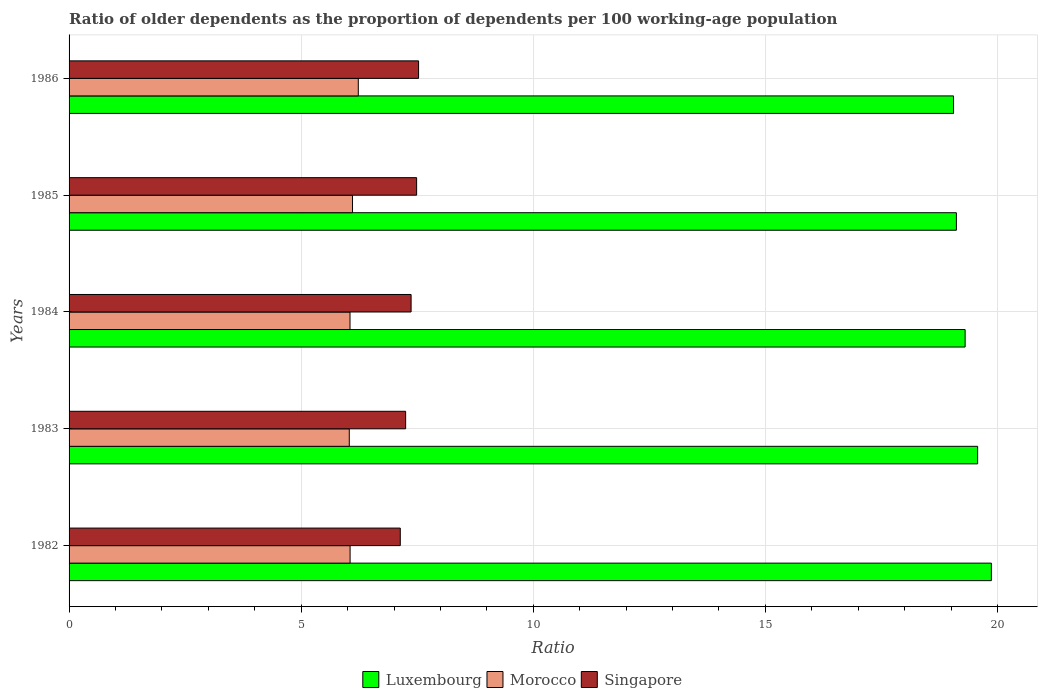How many different coloured bars are there?
Provide a short and direct response. 3. Are the number of bars on each tick of the Y-axis equal?
Your answer should be very brief. Yes. How many bars are there on the 1st tick from the bottom?
Your answer should be very brief. 3. What is the label of the 2nd group of bars from the top?
Your answer should be very brief. 1985. What is the age dependency ratio(old) in Morocco in 1986?
Offer a terse response. 6.23. Across all years, what is the maximum age dependency ratio(old) in Luxembourg?
Your answer should be compact. 19.87. Across all years, what is the minimum age dependency ratio(old) in Morocco?
Ensure brevity in your answer.  6.04. In which year was the age dependency ratio(old) in Morocco maximum?
Give a very brief answer. 1986. What is the total age dependency ratio(old) in Morocco in the graph?
Provide a short and direct response. 30.48. What is the difference between the age dependency ratio(old) in Luxembourg in 1984 and that in 1986?
Your answer should be very brief. 0.25. What is the difference between the age dependency ratio(old) in Luxembourg in 1983 and the age dependency ratio(old) in Morocco in 1982?
Offer a very short reply. 13.52. What is the average age dependency ratio(old) in Morocco per year?
Provide a short and direct response. 6.1. In the year 1985, what is the difference between the age dependency ratio(old) in Luxembourg and age dependency ratio(old) in Singapore?
Provide a short and direct response. 11.63. What is the ratio of the age dependency ratio(old) in Singapore in 1982 to that in 1985?
Offer a very short reply. 0.95. Is the difference between the age dependency ratio(old) in Luxembourg in 1982 and 1986 greater than the difference between the age dependency ratio(old) in Singapore in 1982 and 1986?
Your response must be concise. Yes. What is the difference between the highest and the second highest age dependency ratio(old) in Singapore?
Ensure brevity in your answer.  0.04. What is the difference between the highest and the lowest age dependency ratio(old) in Morocco?
Give a very brief answer. 0.19. In how many years, is the age dependency ratio(old) in Singapore greater than the average age dependency ratio(old) in Singapore taken over all years?
Give a very brief answer. 3. What does the 3rd bar from the top in 1985 represents?
Make the answer very short. Luxembourg. What does the 3rd bar from the bottom in 1982 represents?
Your response must be concise. Singapore. Is it the case that in every year, the sum of the age dependency ratio(old) in Singapore and age dependency ratio(old) in Luxembourg is greater than the age dependency ratio(old) in Morocco?
Your response must be concise. Yes. How many bars are there?
Ensure brevity in your answer.  15. Are all the bars in the graph horizontal?
Keep it short and to the point. Yes. What is the difference between two consecutive major ticks on the X-axis?
Your answer should be very brief. 5. Are the values on the major ticks of X-axis written in scientific E-notation?
Offer a very short reply. No. Does the graph contain any zero values?
Your answer should be very brief. No. Where does the legend appear in the graph?
Your answer should be very brief. Bottom center. How are the legend labels stacked?
Your answer should be compact. Horizontal. What is the title of the graph?
Offer a terse response. Ratio of older dependents as the proportion of dependents per 100 working-age population. What is the label or title of the X-axis?
Give a very brief answer. Ratio. What is the Ratio of Luxembourg in 1982?
Keep it short and to the point. 19.87. What is the Ratio in Morocco in 1982?
Offer a terse response. 6.05. What is the Ratio of Singapore in 1982?
Keep it short and to the point. 7.14. What is the Ratio in Luxembourg in 1983?
Your answer should be compact. 19.57. What is the Ratio of Morocco in 1983?
Ensure brevity in your answer.  6.04. What is the Ratio of Singapore in 1983?
Offer a terse response. 7.25. What is the Ratio in Luxembourg in 1984?
Keep it short and to the point. 19.3. What is the Ratio of Morocco in 1984?
Your answer should be compact. 6.05. What is the Ratio in Singapore in 1984?
Make the answer very short. 7.37. What is the Ratio in Luxembourg in 1985?
Keep it short and to the point. 19.12. What is the Ratio in Morocco in 1985?
Your answer should be very brief. 6.11. What is the Ratio of Singapore in 1985?
Your answer should be very brief. 7.49. What is the Ratio of Luxembourg in 1986?
Keep it short and to the point. 19.05. What is the Ratio of Morocco in 1986?
Provide a succinct answer. 6.23. What is the Ratio in Singapore in 1986?
Make the answer very short. 7.53. Across all years, what is the maximum Ratio in Luxembourg?
Provide a succinct answer. 19.87. Across all years, what is the maximum Ratio in Morocco?
Ensure brevity in your answer.  6.23. Across all years, what is the maximum Ratio in Singapore?
Your response must be concise. 7.53. Across all years, what is the minimum Ratio in Luxembourg?
Provide a succinct answer. 19.05. Across all years, what is the minimum Ratio in Morocco?
Your answer should be very brief. 6.04. Across all years, what is the minimum Ratio in Singapore?
Offer a terse response. 7.14. What is the total Ratio in Luxembourg in the graph?
Provide a succinct answer. 96.92. What is the total Ratio in Morocco in the graph?
Give a very brief answer. 30.48. What is the total Ratio in Singapore in the graph?
Offer a terse response. 36.77. What is the difference between the Ratio of Luxembourg in 1982 and that in 1983?
Your answer should be compact. 0.3. What is the difference between the Ratio of Morocco in 1982 and that in 1983?
Provide a short and direct response. 0.02. What is the difference between the Ratio of Singapore in 1982 and that in 1983?
Offer a terse response. -0.12. What is the difference between the Ratio of Luxembourg in 1982 and that in 1984?
Your answer should be compact. 0.57. What is the difference between the Ratio of Morocco in 1982 and that in 1984?
Your answer should be compact. 0. What is the difference between the Ratio of Singapore in 1982 and that in 1984?
Offer a terse response. -0.23. What is the difference between the Ratio in Luxembourg in 1982 and that in 1985?
Your answer should be very brief. 0.75. What is the difference between the Ratio in Morocco in 1982 and that in 1985?
Provide a short and direct response. -0.05. What is the difference between the Ratio in Singapore in 1982 and that in 1985?
Give a very brief answer. -0.35. What is the difference between the Ratio in Luxembourg in 1982 and that in 1986?
Offer a very short reply. 0.82. What is the difference between the Ratio in Morocco in 1982 and that in 1986?
Make the answer very short. -0.18. What is the difference between the Ratio of Singapore in 1982 and that in 1986?
Make the answer very short. -0.39. What is the difference between the Ratio of Luxembourg in 1983 and that in 1984?
Your response must be concise. 0.27. What is the difference between the Ratio in Morocco in 1983 and that in 1984?
Offer a terse response. -0.02. What is the difference between the Ratio of Singapore in 1983 and that in 1984?
Your answer should be very brief. -0.12. What is the difference between the Ratio of Luxembourg in 1983 and that in 1985?
Give a very brief answer. 0.46. What is the difference between the Ratio of Morocco in 1983 and that in 1985?
Your answer should be compact. -0.07. What is the difference between the Ratio in Singapore in 1983 and that in 1985?
Offer a terse response. -0.24. What is the difference between the Ratio of Luxembourg in 1983 and that in 1986?
Your answer should be compact. 0.52. What is the difference between the Ratio in Morocco in 1983 and that in 1986?
Provide a succinct answer. -0.19. What is the difference between the Ratio of Singapore in 1983 and that in 1986?
Your answer should be very brief. -0.28. What is the difference between the Ratio in Luxembourg in 1984 and that in 1985?
Keep it short and to the point. 0.19. What is the difference between the Ratio in Morocco in 1984 and that in 1985?
Provide a short and direct response. -0.05. What is the difference between the Ratio of Singapore in 1984 and that in 1985?
Give a very brief answer. -0.12. What is the difference between the Ratio of Luxembourg in 1984 and that in 1986?
Provide a succinct answer. 0.25. What is the difference between the Ratio of Morocco in 1984 and that in 1986?
Give a very brief answer. -0.18. What is the difference between the Ratio of Singapore in 1984 and that in 1986?
Ensure brevity in your answer.  -0.16. What is the difference between the Ratio in Luxembourg in 1985 and that in 1986?
Provide a short and direct response. 0.06. What is the difference between the Ratio in Morocco in 1985 and that in 1986?
Offer a very short reply. -0.12. What is the difference between the Ratio of Singapore in 1985 and that in 1986?
Keep it short and to the point. -0.04. What is the difference between the Ratio in Luxembourg in 1982 and the Ratio in Morocco in 1983?
Provide a short and direct response. 13.83. What is the difference between the Ratio of Luxembourg in 1982 and the Ratio of Singapore in 1983?
Ensure brevity in your answer.  12.62. What is the difference between the Ratio of Morocco in 1982 and the Ratio of Singapore in 1983?
Make the answer very short. -1.2. What is the difference between the Ratio of Luxembourg in 1982 and the Ratio of Morocco in 1984?
Your answer should be compact. 13.82. What is the difference between the Ratio in Luxembourg in 1982 and the Ratio in Singapore in 1984?
Your answer should be very brief. 12.5. What is the difference between the Ratio of Morocco in 1982 and the Ratio of Singapore in 1984?
Provide a succinct answer. -1.31. What is the difference between the Ratio in Luxembourg in 1982 and the Ratio in Morocco in 1985?
Your answer should be compact. 13.76. What is the difference between the Ratio in Luxembourg in 1982 and the Ratio in Singapore in 1985?
Offer a very short reply. 12.38. What is the difference between the Ratio of Morocco in 1982 and the Ratio of Singapore in 1985?
Give a very brief answer. -1.43. What is the difference between the Ratio of Luxembourg in 1982 and the Ratio of Morocco in 1986?
Provide a short and direct response. 13.64. What is the difference between the Ratio in Luxembourg in 1982 and the Ratio in Singapore in 1986?
Keep it short and to the point. 12.34. What is the difference between the Ratio in Morocco in 1982 and the Ratio in Singapore in 1986?
Your response must be concise. -1.48. What is the difference between the Ratio in Luxembourg in 1983 and the Ratio in Morocco in 1984?
Make the answer very short. 13.52. What is the difference between the Ratio in Luxembourg in 1983 and the Ratio in Singapore in 1984?
Give a very brief answer. 12.2. What is the difference between the Ratio in Morocco in 1983 and the Ratio in Singapore in 1984?
Ensure brevity in your answer.  -1.33. What is the difference between the Ratio in Luxembourg in 1983 and the Ratio in Morocco in 1985?
Keep it short and to the point. 13.47. What is the difference between the Ratio in Luxembourg in 1983 and the Ratio in Singapore in 1985?
Your answer should be compact. 12.09. What is the difference between the Ratio in Morocco in 1983 and the Ratio in Singapore in 1985?
Provide a short and direct response. -1.45. What is the difference between the Ratio of Luxembourg in 1983 and the Ratio of Morocco in 1986?
Your response must be concise. 13.34. What is the difference between the Ratio in Luxembourg in 1983 and the Ratio in Singapore in 1986?
Your answer should be compact. 12.04. What is the difference between the Ratio in Morocco in 1983 and the Ratio in Singapore in 1986?
Give a very brief answer. -1.49. What is the difference between the Ratio in Luxembourg in 1984 and the Ratio in Morocco in 1985?
Your response must be concise. 13.2. What is the difference between the Ratio of Luxembourg in 1984 and the Ratio of Singapore in 1985?
Provide a succinct answer. 11.82. What is the difference between the Ratio of Morocco in 1984 and the Ratio of Singapore in 1985?
Your response must be concise. -1.44. What is the difference between the Ratio in Luxembourg in 1984 and the Ratio in Morocco in 1986?
Offer a very short reply. 13.07. What is the difference between the Ratio in Luxembourg in 1984 and the Ratio in Singapore in 1986?
Your answer should be very brief. 11.77. What is the difference between the Ratio in Morocco in 1984 and the Ratio in Singapore in 1986?
Make the answer very short. -1.48. What is the difference between the Ratio in Luxembourg in 1985 and the Ratio in Morocco in 1986?
Your response must be concise. 12.88. What is the difference between the Ratio of Luxembourg in 1985 and the Ratio of Singapore in 1986?
Keep it short and to the point. 11.59. What is the difference between the Ratio of Morocco in 1985 and the Ratio of Singapore in 1986?
Make the answer very short. -1.42. What is the average Ratio in Luxembourg per year?
Make the answer very short. 19.38. What is the average Ratio of Morocco per year?
Ensure brevity in your answer.  6.1. What is the average Ratio of Singapore per year?
Provide a short and direct response. 7.35. In the year 1982, what is the difference between the Ratio of Luxembourg and Ratio of Morocco?
Give a very brief answer. 13.82. In the year 1982, what is the difference between the Ratio of Luxembourg and Ratio of Singapore?
Make the answer very short. 12.73. In the year 1982, what is the difference between the Ratio of Morocco and Ratio of Singapore?
Give a very brief answer. -1.08. In the year 1983, what is the difference between the Ratio of Luxembourg and Ratio of Morocco?
Ensure brevity in your answer.  13.54. In the year 1983, what is the difference between the Ratio in Luxembourg and Ratio in Singapore?
Make the answer very short. 12.32. In the year 1983, what is the difference between the Ratio of Morocco and Ratio of Singapore?
Give a very brief answer. -1.21. In the year 1984, what is the difference between the Ratio of Luxembourg and Ratio of Morocco?
Give a very brief answer. 13.25. In the year 1984, what is the difference between the Ratio of Luxembourg and Ratio of Singapore?
Ensure brevity in your answer.  11.94. In the year 1984, what is the difference between the Ratio of Morocco and Ratio of Singapore?
Ensure brevity in your answer.  -1.32. In the year 1985, what is the difference between the Ratio of Luxembourg and Ratio of Morocco?
Provide a succinct answer. 13.01. In the year 1985, what is the difference between the Ratio in Luxembourg and Ratio in Singapore?
Provide a succinct answer. 11.63. In the year 1985, what is the difference between the Ratio of Morocco and Ratio of Singapore?
Keep it short and to the point. -1.38. In the year 1986, what is the difference between the Ratio in Luxembourg and Ratio in Morocco?
Your response must be concise. 12.82. In the year 1986, what is the difference between the Ratio in Luxembourg and Ratio in Singapore?
Provide a succinct answer. 11.52. In the year 1986, what is the difference between the Ratio in Morocco and Ratio in Singapore?
Make the answer very short. -1.3. What is the ratio of the Ratio in Luxembourg in 1982 to that in 1983?
Ensure brevity in your answer.  1.02. What is the ratio of the Ratio in Morocco in 1982 to that in 1983?
Provide a short and direct response. 1. What is the ratio of the Ratio in Singapore in 1982 to that in 1983?
Your response must be concise. 0.98. What is the ratio of the Ratio in Luxembourg in 1982 to that in 1984?
Provide a short and direct response. 1.03. What is the ratio of the Ratio in Morocco in 1982 to that in 1984?
Give a very brief answer. 1. What is the ratio of the Ratio in Singapore in 1982 to that in 1984?
Provide a short and direct response. 0.97. What is the ratio of the Ratio of Luxembourg in 1982 to that in 1985?
Make the answer very short. 1.04. What is the ratio of the Ratio of Singapore in 1982 to that in 1985?
Offer a very short reply. 0.95. What is the ratio of the Ratio in Luxembourg in 1982 to that in 1986?
Your response must be concise. 1.04. What is the ratio of the Ratio in Morocco in 1982 to that in 1986?
Provide a succinct answer. 0.97. What is the ratio of the Ratio of Singapore in 1982 to that in 1986?
Your answer should be compact. 0.95. What is the ratio of the Ratio in Luxembourg in 1983 to that in 1984?
Offer a very short reply. 1.01. What is the ratio of the Ratio of Morocco in 1983 to that in 1984?
Offer a terse response. 1. What is the ratio of the Ratio in Singapore in 1983 to that in 1984?
Offer a terse response. 0.98. What is the ratio of the Ratio in Luxembourg in 1983 to that in 1985?
Ensure brevity in your answer.  1.02. What is the ratio of the Ratio in Singapore in 1983 to that in 1985?
Give a very brief answer. 0.97. What is the ratio of the Ratio in Luxembourg in 1983 to that in 1986?
Your answer should be very brief. 1.03. What is the ratio of the Ratio in Morocco in 1983 to that in 1986?
Give a very brief answer. 0.97. What is the ratio of the Ratio in Luxembourg in 1984 to that in 1985?
Provide a short and direct response. 1.01. What is the ratio of the Ratio in Singapore in 1984 to that in 1985?
Make the answer very short. 0.98. What is the ratio of the Ratio in Luxembourg in 1984 to that in 1986?
Your answer should be compact. 1.01. What is the ratio of the Ratio in Morocco in 1984 to that in 1986?
Offer a terse response. 0.97. What is the ratio of the Ratio of Singapore in 1984 to that in 1986?
Give a very brief answer. 0.98. What is the ratio of the Ratio in Luxembourg in 1985 to that in 1986?
Your answer should be very brief. 1. What is the ratio of the Ratio in Morocco in 1985 to that in 1986?
Provide a short and direct response. 0.98. What is the ratio of the Ratio in Singapore in 1985 to that in 1986?
Keep it short and to the point. 0.99. What is the difference between the highest and the second highest Ratio in Luxembourg?
Give a very brief answer. 0.3. What is the difference between the highest and the second highest Ratio of Morocco?
Provide a short and direct response. 0.12. What is the difference between the highest and the second highest Ratio of Singapore?
Your answer should be very brief. 0.04. What is the difference between the highest and the lowest Ratio of Luxembourg?
Your answer should be very brief. 0.82. What is the difference between the highest and the lowest Ratio of Morocco?
Ensure brevity in your answer.  0.19. What is the difference between the highest and the lowest Ratio of Singapore?
Provide a short and direct response. 0.39. 